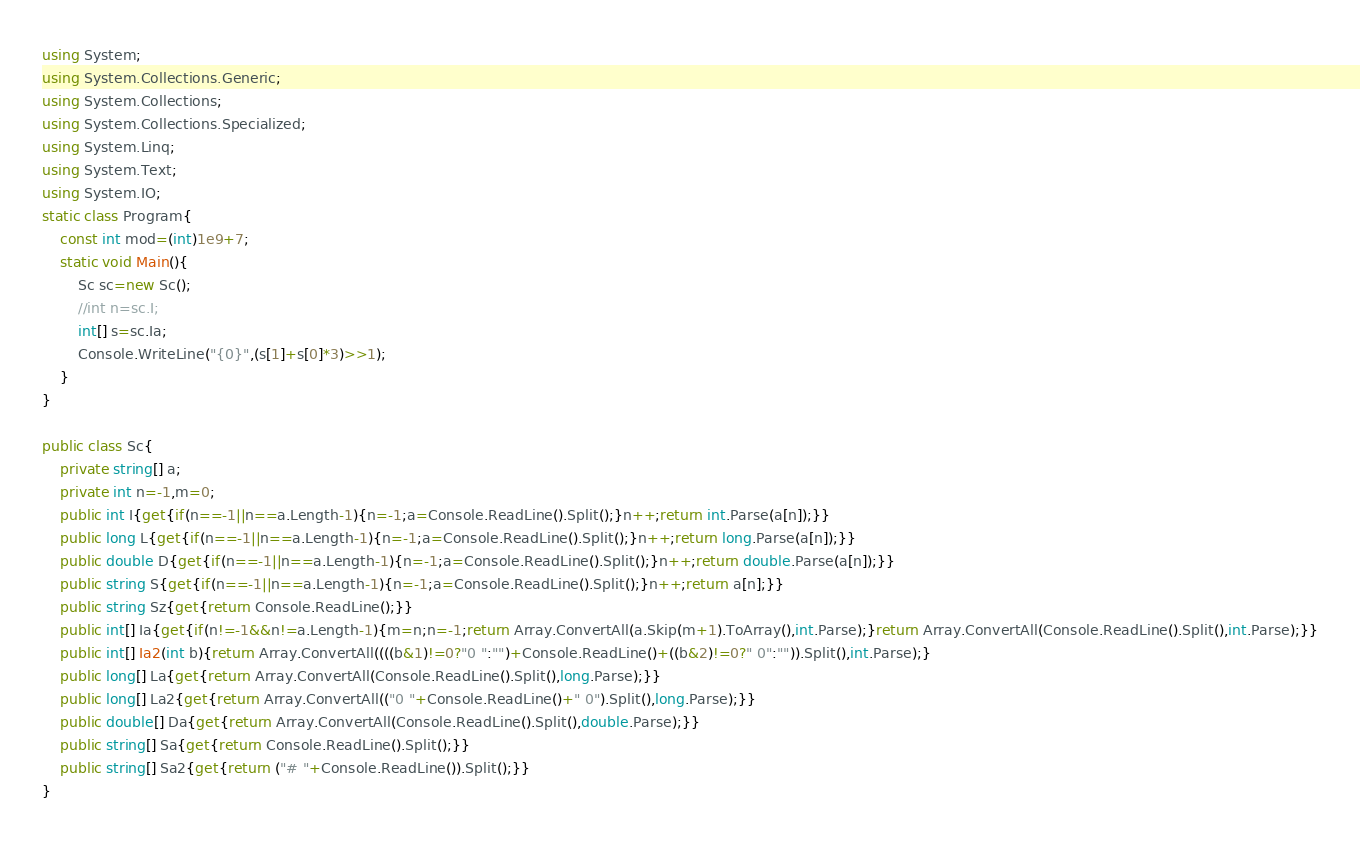Convert code to text. <code><loc_0><loc_0><loc_500><loc_500><_C#_>using System;
using System.Collections.Generic;
using System.Collections;
using System.Collections.Specialized;
using System.Linq;
using System.Text;
using System.IO;
static class Program{
	const int mod=(int)1e9+7;
	static void Main(){
		Sc sc=new Sc();
		//int n=sc.I;
		int[] s=sc.Ia;
		Console.WriteLine("{0}",(s[1]+s[0]*3)>>1);
	}
}

public class Sc{
	private string[] a;
	private int n=-1,m=0;
	public int I{get{if(n==-1||n==a.Length-1){n=-1;a=Console.ReadLine().Split();}n++;return int.Parse(a[n]);}}
	public long L{get{if(n==-1||n==a.Length-1){n=-1;a=Console.ReadLine().Split();}n++;return long.Parse(a[n]);}}
	public double D{get{if(n==-1||n==a.Length-1){n=-1;a=Console.ReadLine().Split();}n++;return double.Parse(a[n]);}}
	public string S{get{if(n==-1||n==a.Length-1){n=-1;a=Console.ReadLine().Split();}n++;return a[n];}}
	public string Sz{get{return Console.ReadLine();}}
	public int[] Ia{get{if(n!=-1&&n!=a.Length-1){m=n;n=-1;return Array.ConvertAll(a.Skip(m+1).ToArray(),int.Parse);}return Array.ConvertAll(Console.ReadLine().Split(),int.Parse);}}
	public int[] Ia2(int b){return Array.ConvertAll((((b&1)!=0?"0 ":"")+Console.ReadLine()+((b&2)!=0?" 0":"")).Split(),int.Parse);}
	public long[] La{get{return Array.ConvertAll(Console.ReadLine().Split(),long.Parse);}}
	public long[] La2{get{return Array.ConvertAll(("0 "+Console.ReadLine()+" 0").Split(),long.Parse);}}
	public double[] Da{get{return Array.ConvertAll(Console.ReadLine().Split(),double.Parse);}}
	public string[] Sa{get{return Console.ReadLine().Split();}}
	public string[] Sa2{get{return ("# "+Console.ReadLine()).Split();}}
}
</code> 